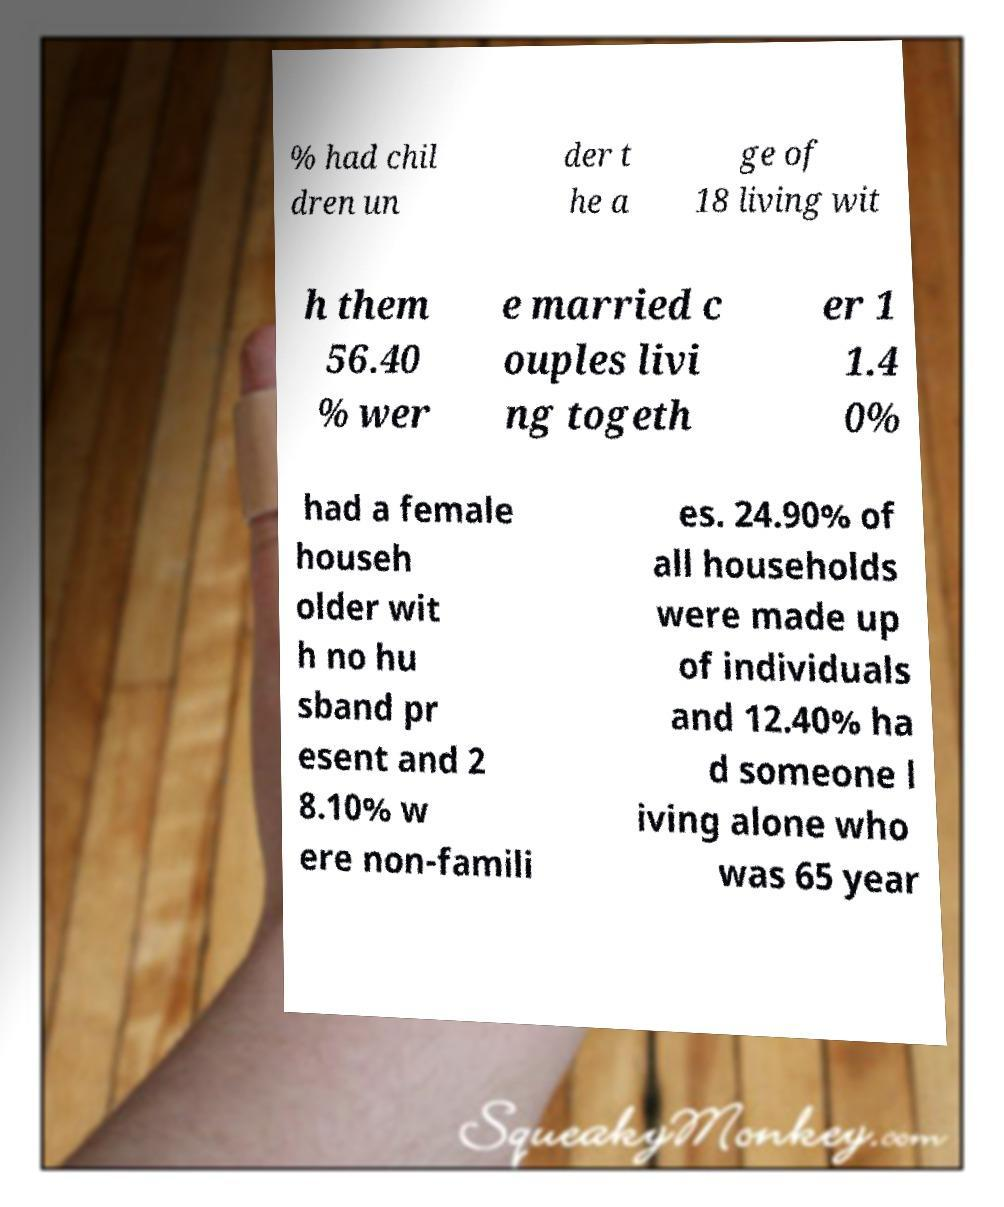What messages or text are displayed in this image? I need them in a readable, typed format. % had chil dren un der t he a ge of 18 living wit h them 56.40 % wer e married c ouples livi ng togeth er 1 1.4 0% had a female househ older wit h no hu sband pr esent and 2 8.10% w ere non-famili es. 24.90% of all households were made up of individuals and 12.40% ha d someone l iving alone who was 65 year 